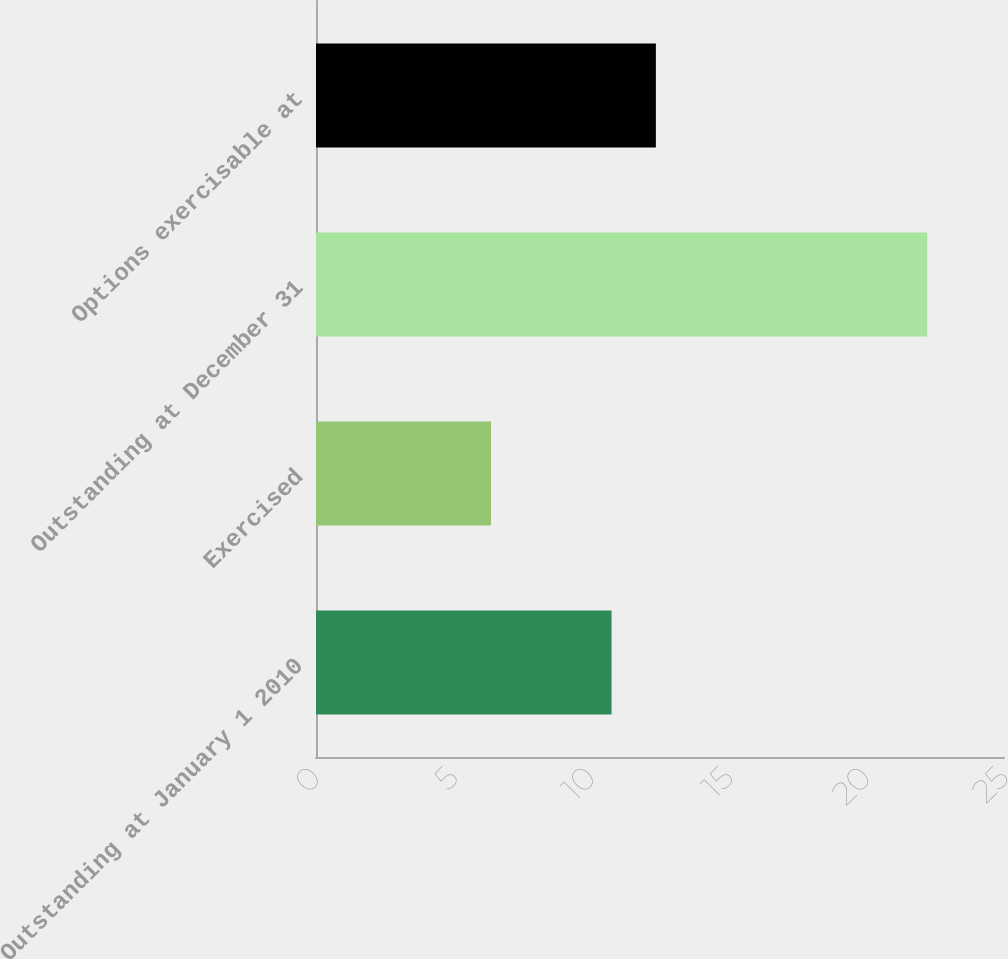<chart> <loc_0><loc_0><loc_500><loc_500><bar_chart><fcel>Outstanding at January 1 2010<fcel>Exercised<fcel>Outstanding at December 31<fcel>Options exercisable at<nl><fcel>10.74<fcel>6.36<fcel>22.21<fcel>12.35<nl></chart> 